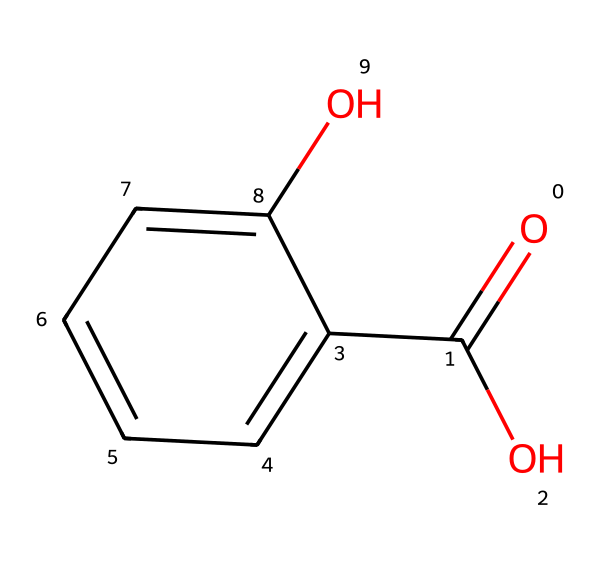What is the molecular formula of salicylic acid? The SMILES representation indicates a total of 7 carbon (C) atoms, 6 hydrogen (H) atoms, and 3 oxygen (O) atoms, giving the molecular formula C7H6O3.
Answer: C7H6O3 How many oxygen atoms are present in salicylic acid? In the given SMILES structure, there are two distinct oxygen atoms: one in the carboxylic acid group (O=C(O)) and one as a hydroxyl group (O).
Answer: 3 What kind of functional groups does salicylic acid contain? By examining the structure, we can identify a carboxylic acid group (–COOH) and a phenolic hydroxyl group (–OH). These functional groups contribute to its properties.
Answer: carboxylic acid and phenolic Is salicylic acid polar or non-polar? Considering the presence of the hydroxyl and carboxylic acid functional groups, which are polar, salicylic acid is classified as a polar compound due to its ability to form hydrogen bonds.
Answer: polar What is the main reason salicylic acid is used in acne treatment? Salicylic acid acts as a keratolytic agent, helping to exfoliate the skin and prevent clogged pores, which is crucial in acne treatment.
Answer: exfoliant How many rings are in the structure of salicylic acid? The provided SMILES indicates one aromatic ring (the benzene part of the structure) that contributes to its chemical properties.
Answer: 1 What is the significance of the hydroxyl group in salicylic acid? The hydroxyl group enhances the compound's solubility in water and its ability to penetrate the skin, making it effective for topical applications in treating acne.
Answer: solubility and penetration 